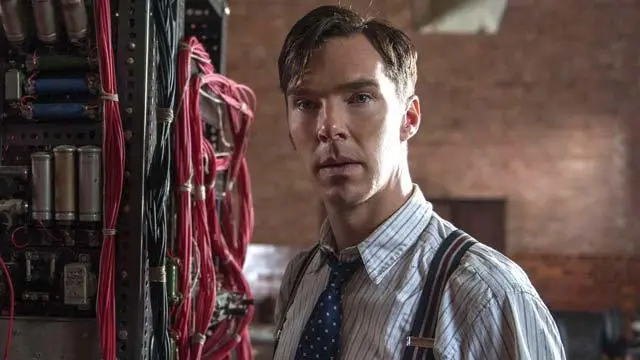What does the setting of the photo tell us about the time period and location? The setting, characterized by the rustic brick wall backdrop and the vintage machinery, suggests a mid-20th century time frame, specifically aligning with the era of World War II or shortly thereafter. The combination of old-school industrial elements with the advanced technological machinery hints at a significant period of scientific and technological transition, likely in a western country engaged in significant wartime or post-war activities. 